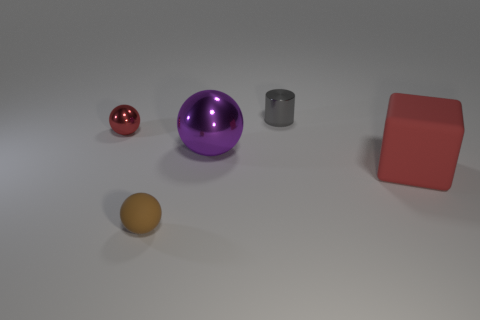Subtract all brown spheres. How many spheres are left? 2 Subtract all purple spheres. How many spheres are left? 2 Add 2 red balls. How many objects exist? 7 Subtract all spheres. How many objects are left? 2 Subtract all yellow balls. Subtract all yellow cylinders. How many balls are left? 3 Subtract 0 yellow cylinders. How many objects are left? 5 Subtract all rubber blocks. Subtract all purple cubes. How many objects are left? 4 Add 5 large purple metal balls. How many large purple metal balls are left? 6 Add 3 small gray things. How many small gray things exist? 4 